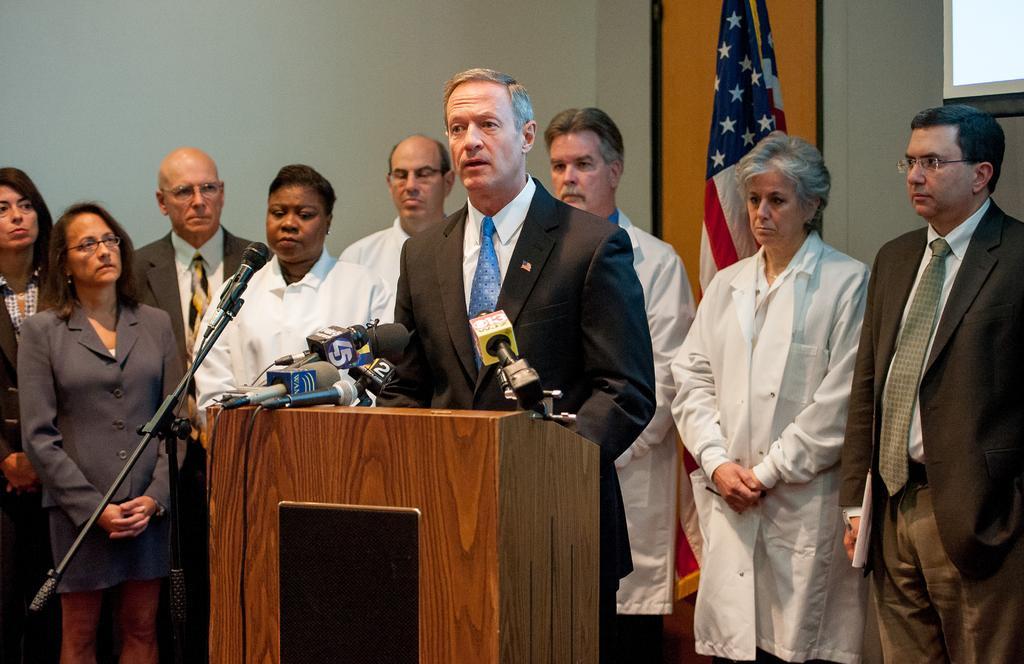Could you give a brief overview of what you see in this image? In this picture there is a person standing behind the podium and he is talking and there are microphones on the podium. At the back there are group of people standing and there is a flag and there is a screen. 